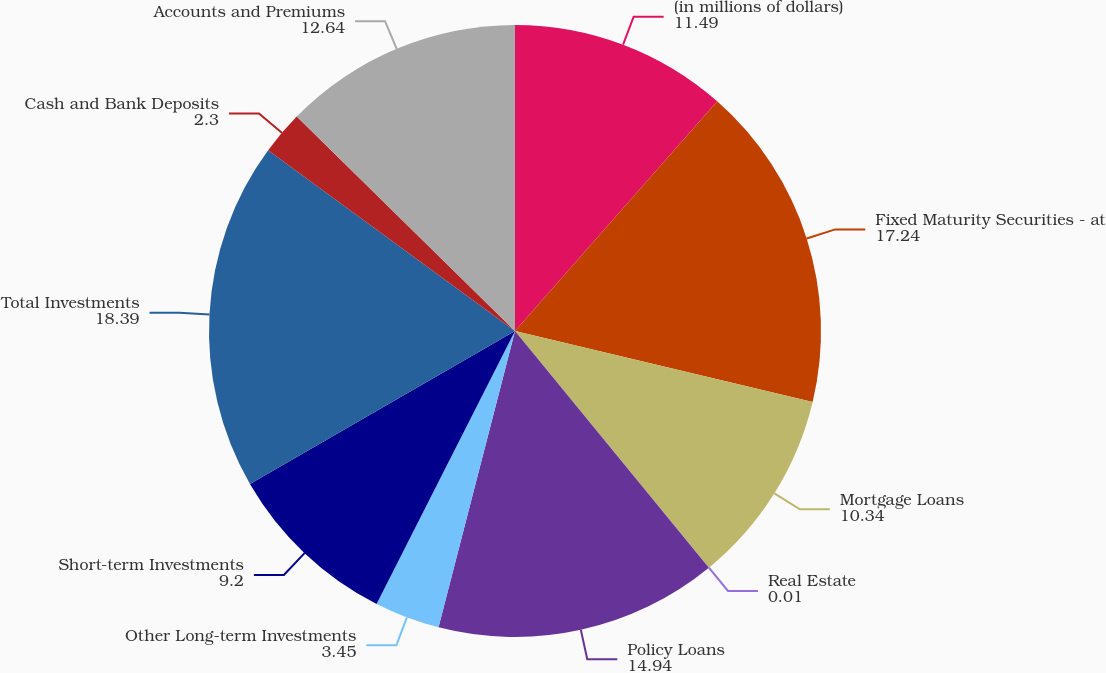Convert chart. <chart><loc_0><loc_0><loc_500><loc_500><pie_chart><fcel>(in millions of dollars)<fcel>Fixed Maturity Securities - at<fcel>Mortgage Loans<fcel>Real Estate<fcel>Policy Loans<fcel>Other Long-term Investments<fcel>Short-term Investments<fcel>Total Investments<fcel>Cash and Bank Deposits<fcel>Accounts and Premiums<nl><fcel>11.49%<fcel>17.24%<fcel>10.34%<fcel>0.01%<fcel>14.94%<fcel>3.45%<fcel>9.2%<fcel>18.39%<fcel>2.3%<fcel>12.64%<nl></chart> 